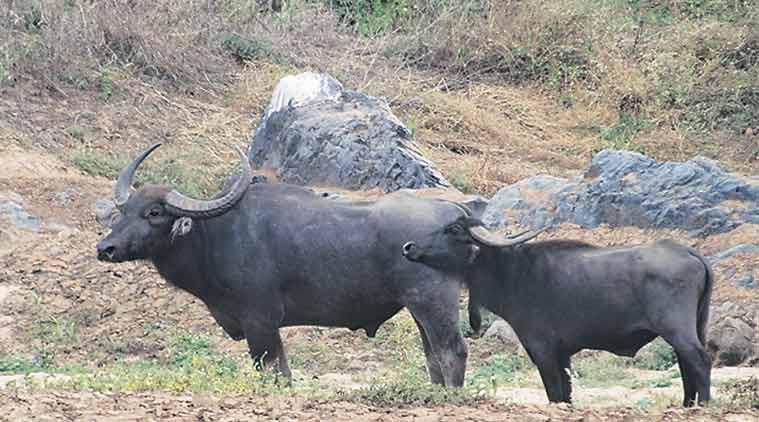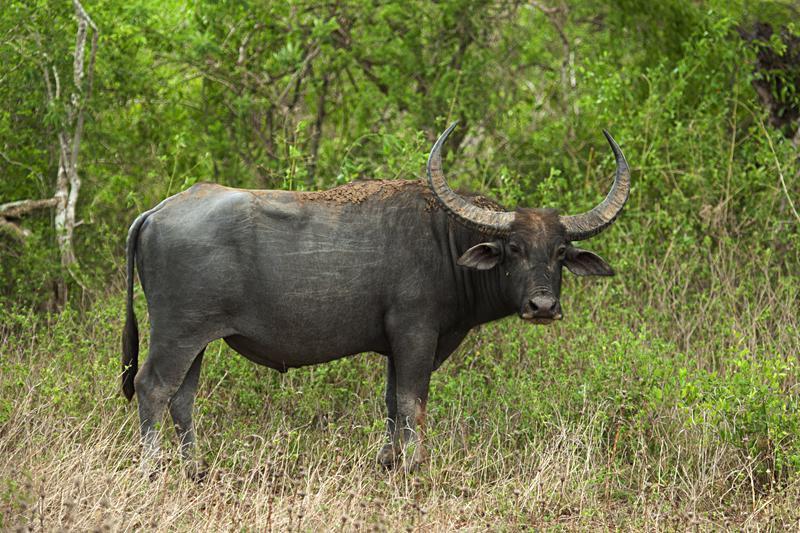The first image is the image on the left, the second image is the image on the right. For the images shown, is this caption "There are exactly two animals in the image on the left." true? Answer yes or no. Yes. The first image is the image on the left, the second image is the image on the right. Evaluate the accuracy of this statement regarding the images: "Two cows are in the picture on the left.". Is it true? Answer yes or no. Yes. 